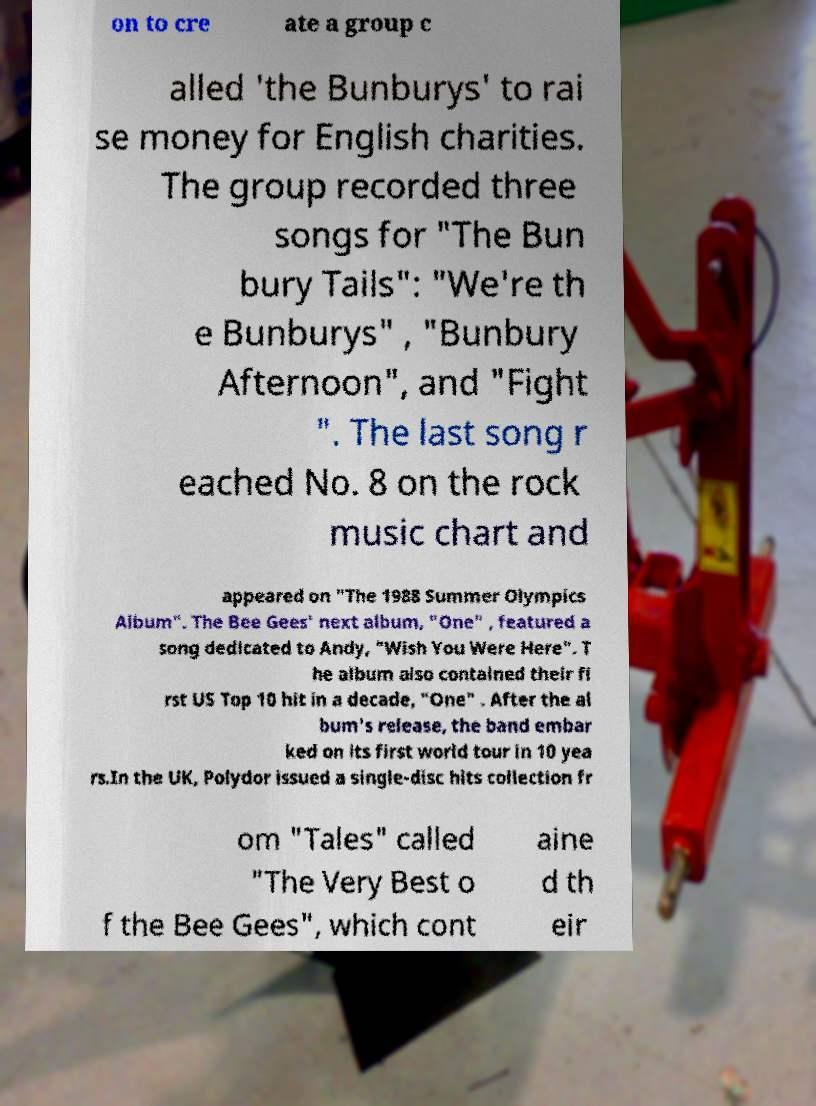What messages or text are displayed in this image? I need them in a readable, typed format. on to cre ate a group c alled 'the Bunburys' to rai se money for English charities. The group recorded three songs for "The Bun bury Tails": "We're th e Bunburys" , "Bunbury Afternoon", and "Fight ". The last song r eached No. 8 on the rock music chart and appeared on "The 1988 Summer Olympics Album". The Bee Gees' next album, "One" , featured a song dedicated to Andy, "Wish You Were Here". T he album also contained their fi rst US Top 10 hit in a decade, "One" . After the al bum's release, the band embar ked on its first world tour in 10 yea rs.In the UK, Polydor issued a single-disc hits collection fr om "Tales" called "The Very Best o f the Bee Gees", which cont aine d th eir 